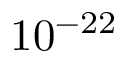<formula> <loc_0><loc_0><loc_500><loc_500>1 0 ^ { - 2 2 }</formula> 